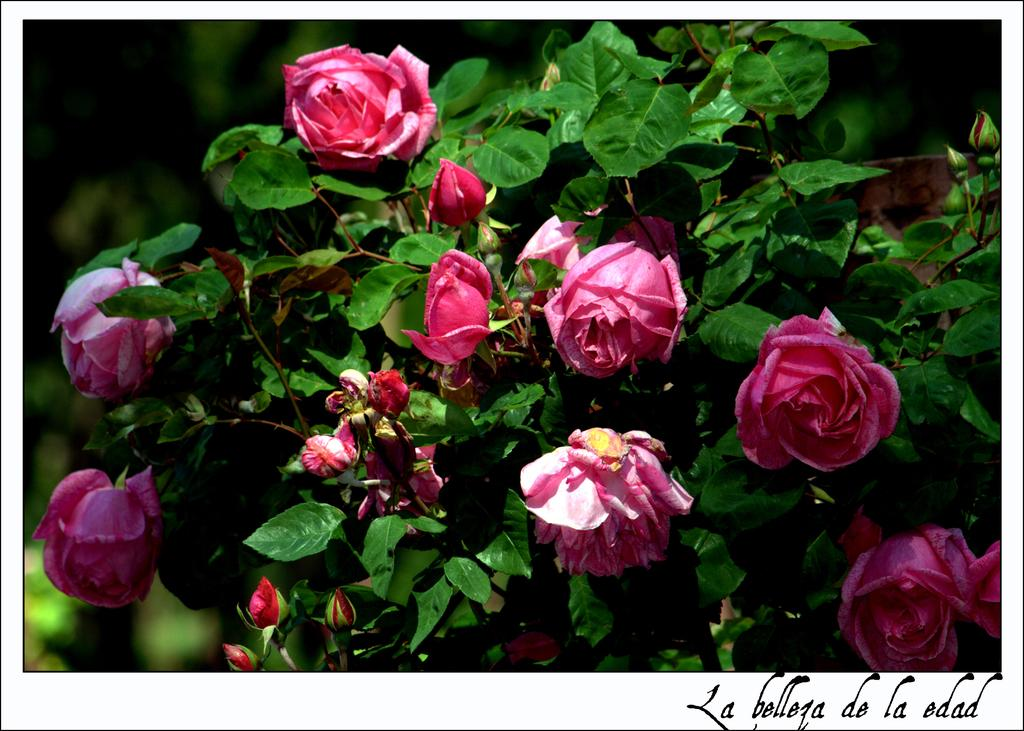What color are the flowers in the image? The flowers in the image are pink. What else can be seen in the image besides the flowers? There are plants in the image. What type of butter is being used to paint the floor in the image? There is no butter or painting activity present in the image. The image only subjects are flowers and plants, and there is no mention of butter or floor in the provided facts. 